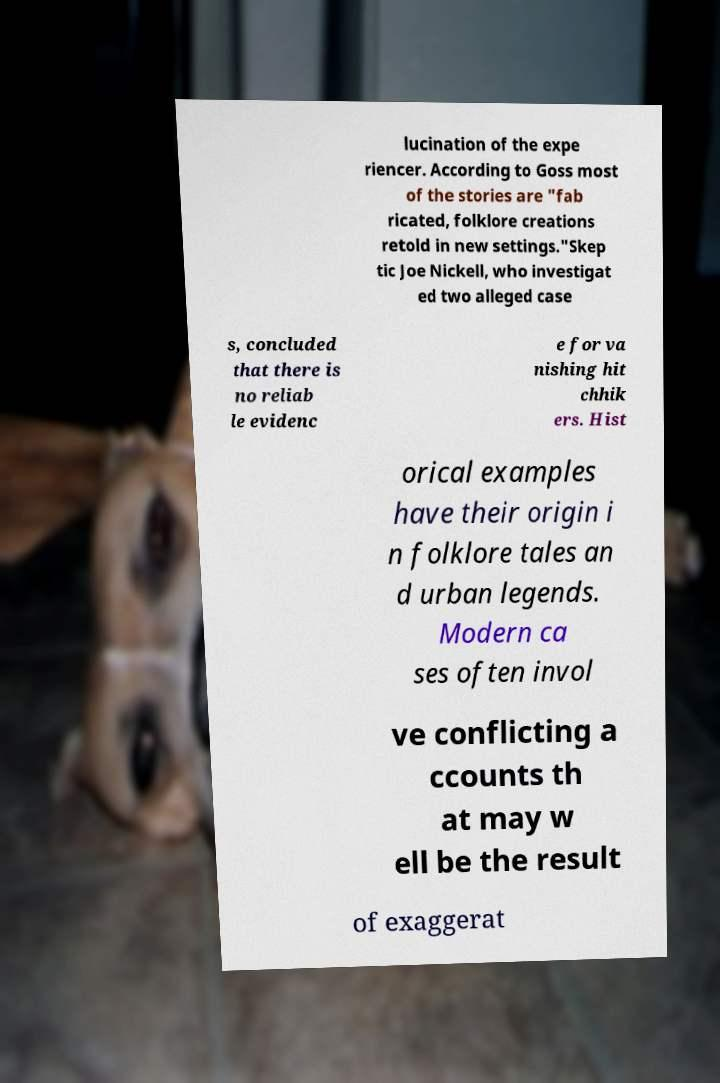Can you read and provide the text displayed in the image?This photo seems to have some interesting text. Can you extract and type it out for me? lucination of the expe riencer. According to Goss most of the stories are "fab ricated, folklore creations retold in new settings."Skep tic Joe Nickell, who investigat ed two alleged case s, concluded that there is no reliab le evidenc e for va nishing hit chhik ers. Hist orical examples have their origin i n folklore tales an d urban legends. Modern ca ses often invol ve conflicting a ccounts th at may w ell be the result of exaggerat 